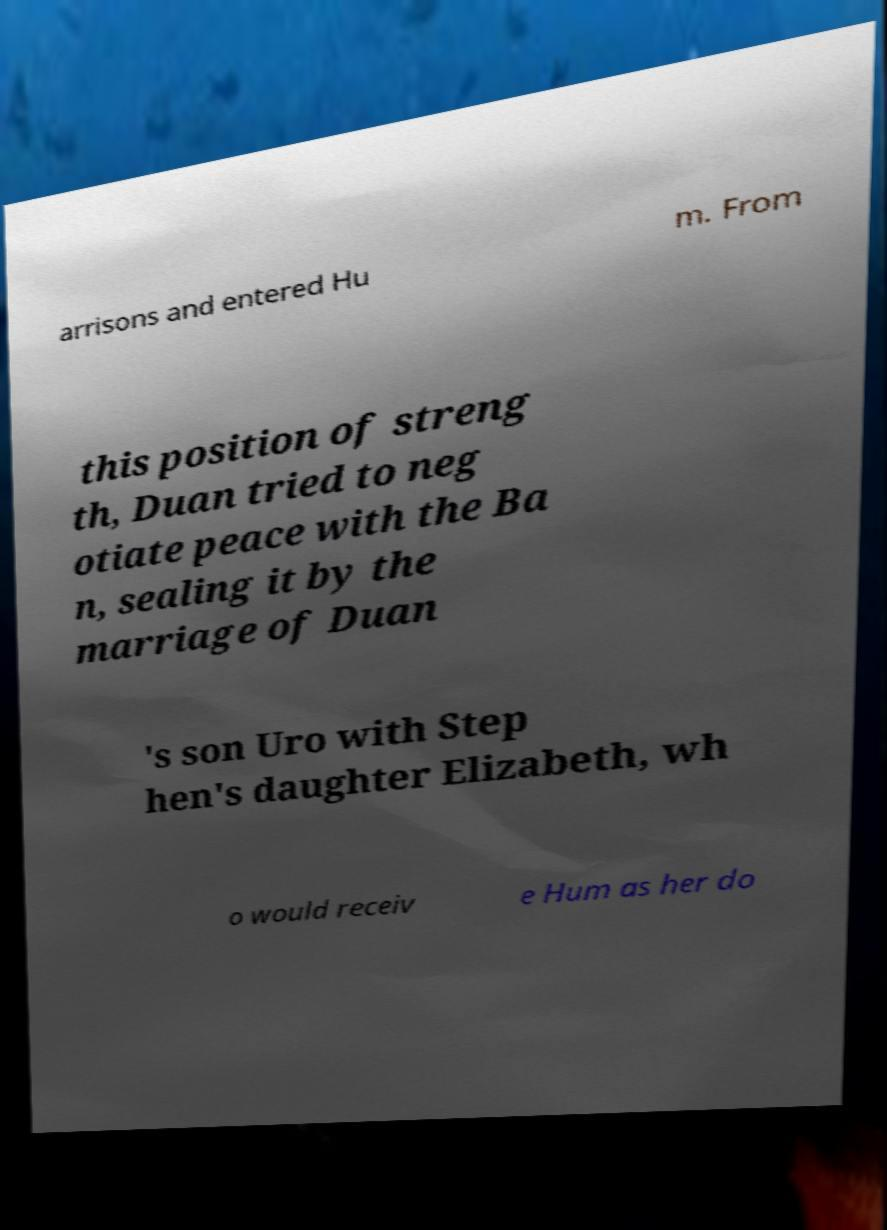Please read and relay the text visible in this image. What does it say? arrisons and entered Hu m. From this position of streng th, Duan tried to neg otiate peace with the Ba n, sealing it by the marriage of Duan 's son Uro with Step hen's daughter Elizabeth, wh o would receiv e Hum as her do 